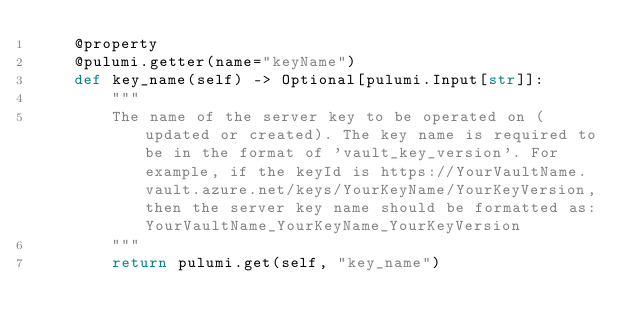Convert code to text. <code><loc_0><loc_0><loc_500><loc_500><_Python_>    @property
    @pulumi.getter(name="keyName")
    def key_name(self) -> Optional[pulumi.Input[str]]:
        """
        The name of the server key to be operated on (updated or created). The key name is required to be in the format of 'vault_key_version'. For example, if the keyId is https://YourVaultName.vault.azure.net/keys/YourKeyName/YourKeyVersion, then the server key name should be formatted as: YourVaultName_YourKeyName_YourKeyVersion
        """
        return pulumi.get(self, "key_name")
</code> 